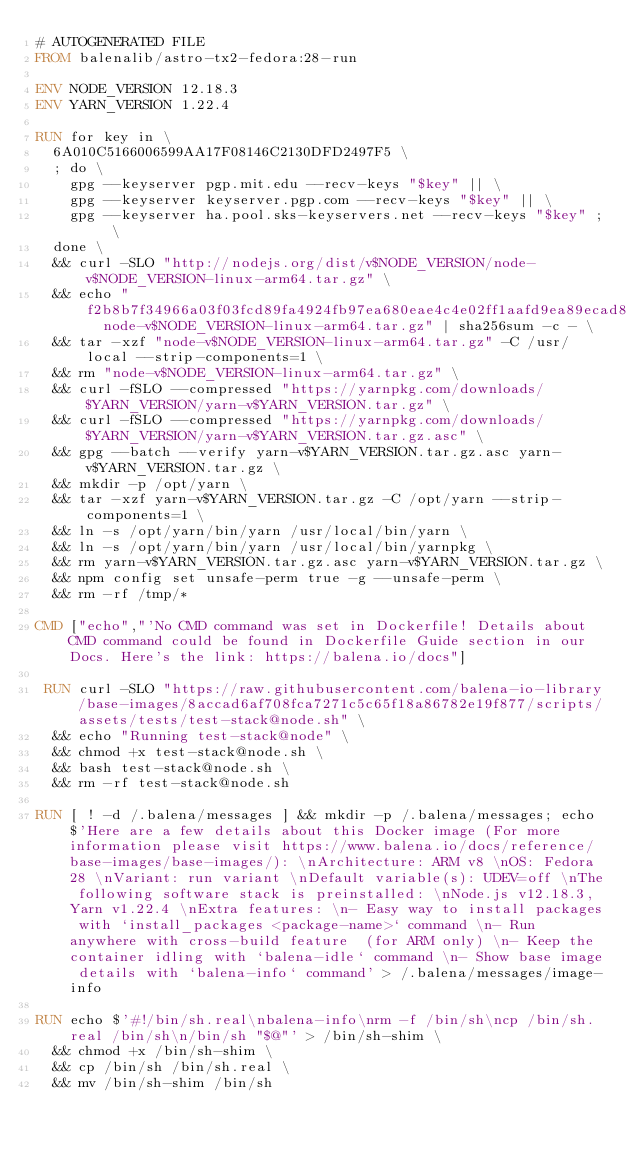Convert code to text. <code><loc_0><loc_0><loc_500><loc_500><_Dockerfile_># AUTOGENERATED FILE
FROM balenalib/astro-tx2-fedora:28-run

ENV NODE_VERSION 12.18.3
ENV YARN_VERSION 1.22.4

RUN for key in \
	6A010C5166006599AA17F08146C2130DFD2497F5 \
	; do \
		gpg --keyserver pgp.mit.edu --recv-keys "$key" || \
		gpg --keyserver keyserver.pgp.com --recv-keys "$key" || \
		gpg --keyserver ha.pool.sks-keyservers.net --recv-keys "$key" ; \
	done \
	&& curl -SLO "http://nodejs.org/dist/v$NODE_VERSION/node-v$NODE_VERSION-linux-arm64.tar.gz" \
	&& echo "f2b8b7f34966a03f03fcd89fa4924fb97ea680eae4c4e02ff1aafd9ea89ecad8  node-v$NODE_VERSION-linux-arm64.tar.gz" | sha256sum -c - \
	&& tar -xzf "node-v$NODE_VERSION-linux-arm64.tar.gz" -C /usr/local --strip-components=1 \
	&& rm "node-v$NODE_VERSION-linux-arm64.tar.gz" \
	&& curl -fSLO --compressed "https://yarnpkg.com/downloads/$YARN_VERSION/yarn-v$YARN_VERSION.tar.gz" \
	&& curl -fSLO --compressed "https://yarnpkg.com/downloads/$YARN_VERSION/yarn-v$YARN_VERSION.tar.gz.asc" \
	&& gpg --batch --verify yarn-v$YARN_VERSION.tar.gz.asc yarn-v$YARN_VERSION.tar.gz \
	&& mkdir -p /opt/yarn \
	&& tar -xzf yarn-v$YARN_VERSION.tar.gz -C /opt/yarn --strip-components=1 \
	&& ln -s /opt/yarn/bin/yarn /usr/local/bin/yarn \
	&& ln -s /opt/yarn/bin/yarn /usr/local/bin/yarnpkg \
	&& rm yarn-v$YARN_VERSION.tar.gz.asc yarn-v$YARN_VERSION.tar.gz \
	&& npm config set unsafe-perm true -g --unsafe-perm \
	&& rm -rf /tmp/*

CMD ["echo","'No CMD command was set in Dockerfile! Details about CMD command could be found in Dockerfile Guide section in our Docs. Here's the link: https://balena.io/docs"]

 RUN curl -SLO "https://raw.githubusercontent.com/balena-io-library/base-images/8accad6af708fca7271c5c65f18a86782e19f877/scripts/assets/tests/test-stack@node.sh" \
  && echo "Running test-stack@node" \
  && chmod +x test-stack@node.sh \
  && bash test-stack@node.sh \
  && rm -rf test-stack@node.sh 

RUN [ ! -d /.balena/messages ] && mkdir -p /.balena/messages; echo $'Here are a few details about this Docker image (For more information please visit https://www.balena.io/docs/reference/base-images/base-images/): \nArchitecture: ARM v8 \nOS: Fedora 28 \nVariant: run variant \nDefault variable(s): UDEV=off \nThe following software stack is preinstalled: \nNode.js v12.18.3, Yarn v1.22.4 \nExtra features: \n- Easy way to install packages with `install_packages <package-name>` command \n- Run anywhere with cross-build feature  (for ARM only) \n- Keep the container idling with `balena-idle` command \n- Show base image details with `balena-info` command' > /.balena/messages/image-info

RUN echo $'#!/bin/sh.real\nbalena-info\nrm -f /bin/sh\ncp /bin/sh.real /bin/sh\n/bin/sh "$@"' > /bin/sh-shim \
	&& chmod +x /bin/sh-shim \
	&& cp /bin/sh /bin/sh.real \
	&& mv /bin/sh-shim /bin/sh</code> 